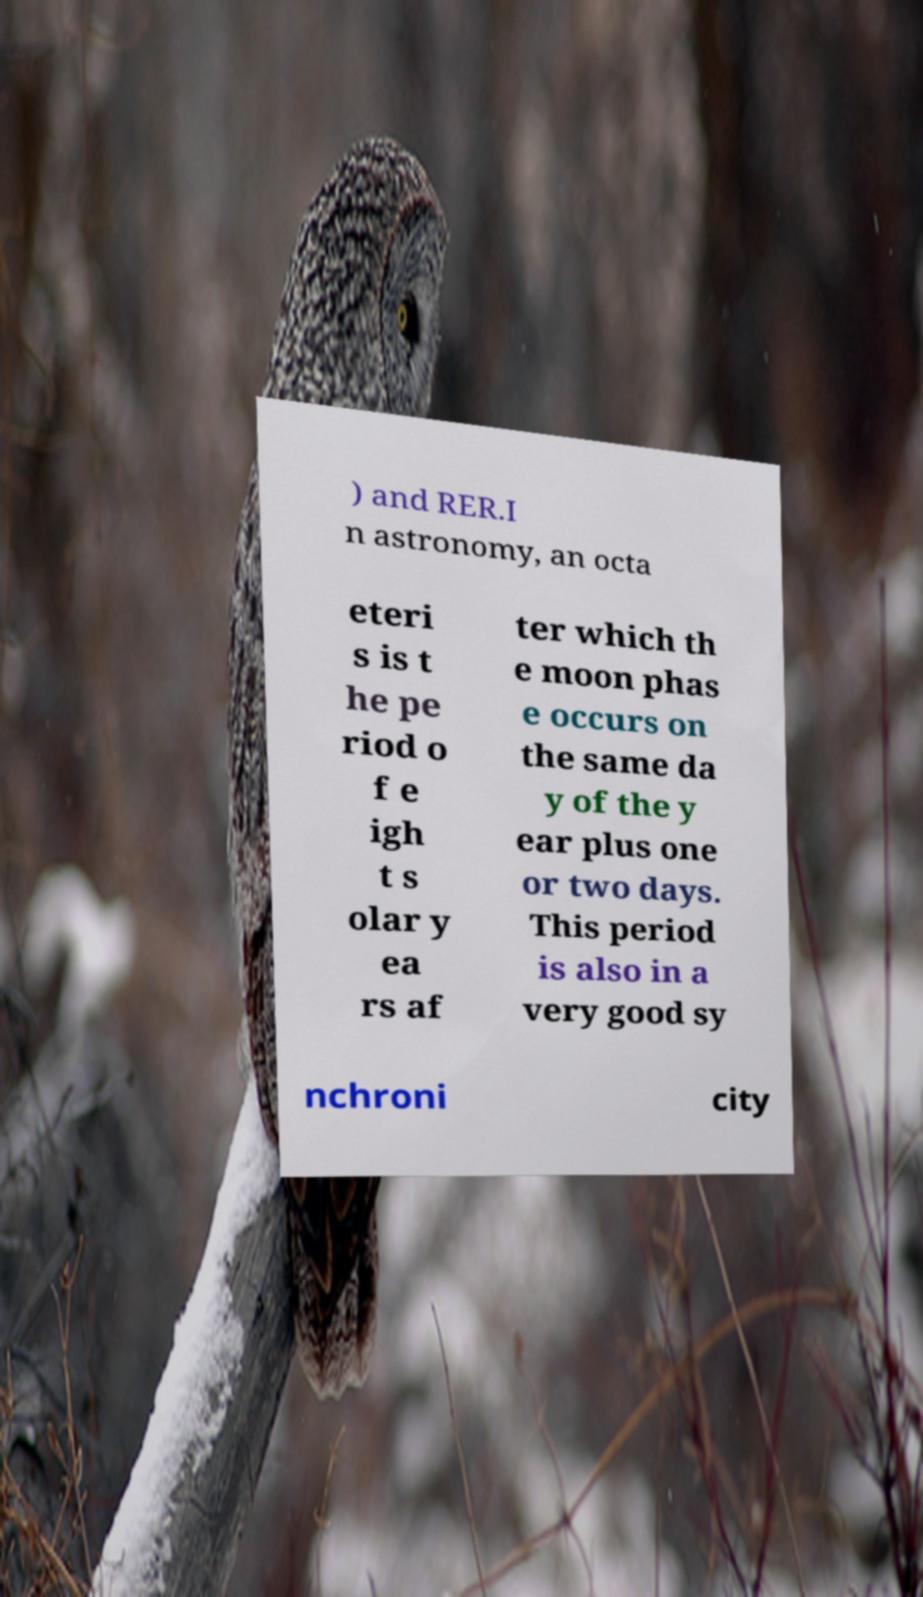Could you assist in decoding the text presented in this image and type it out clearly? ) and RER.I n astronomy, an octa eteri s is t he pe riod o f e igh t s olar y ea rs af ter which th e moon phas e occurs on the same da y of the y ear plus one or two days. This period is also in a very good sy nchroni city 